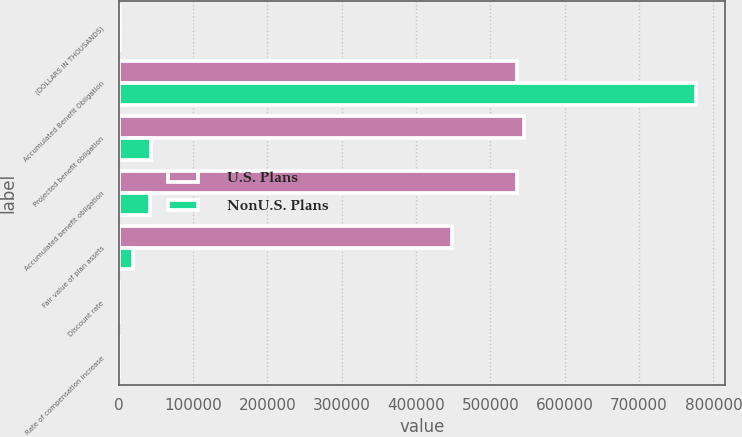<chart> <loc_0><loc_0><loc_500><loc_500><stacked_bar_chart><ecel><fcel>(DOLLARS IN THOUSANDS)<fcel>Accumulated Benefit Obligation<fcel>Projected benefit obligation<fcel>Accumulated benefit obligation<fcel>Fair value of plan assets<fcel>Discount rate<fcel>Rate of compensation increase<nl><fcel>U.S. Plans<fcel>2013<fcel>536176<fcel>544602<fcel>536176<fcel>448851<fcel>4.7<fcel>3.25<nl><fcel>NonU.S. Plans<fcel>2013<fcel>777188<fcel>43778<fcel>41991<fcel>18669<fcel>4.18<fcel>2.66<nl></chart> 